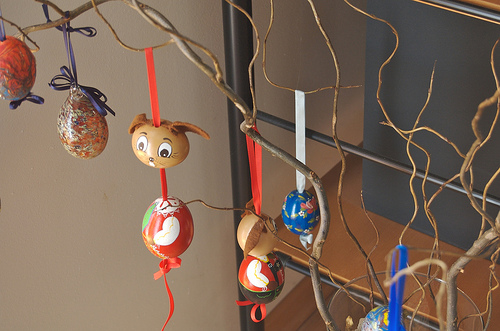<image>
Is there a body in front of the head? No. The body is not in front of the head. The spatial positioning shows a different relationship between these objects. 